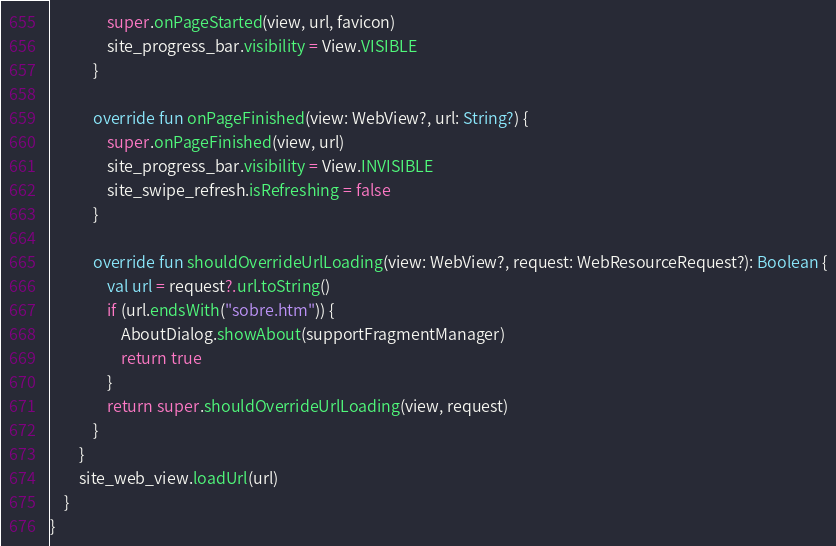<code> <loc_0><loc_0><loc_500><loc_500><_Kotlin_>                super.onPageStarted(view, url, favicon)
                site_progress_bar.visibility = View.VISIBLE
            }

            override fun onPageFinished(view: WebView?, url: String?) {
                super.onPageFinished(view, url)
                site_progress_bar.visibility = View.INVISIBLE
                site_swipe_refresh.isRefreshing = false
            }

            override fun shouldOverrideUrlLoading(view: WebView?, request: WebResourceRequest?): Boolean {
                val url = request?.url.toString()
                if (url.endsWith("sobre.htm")) {
                    AboutDialog.showAbout(supportFragmentManager)
                    return true
                }
                return super.shouldOverrideUrlLoading(view, request)
            }
        }
        site_web_view.loadUrl(url)
    }
}</code> 